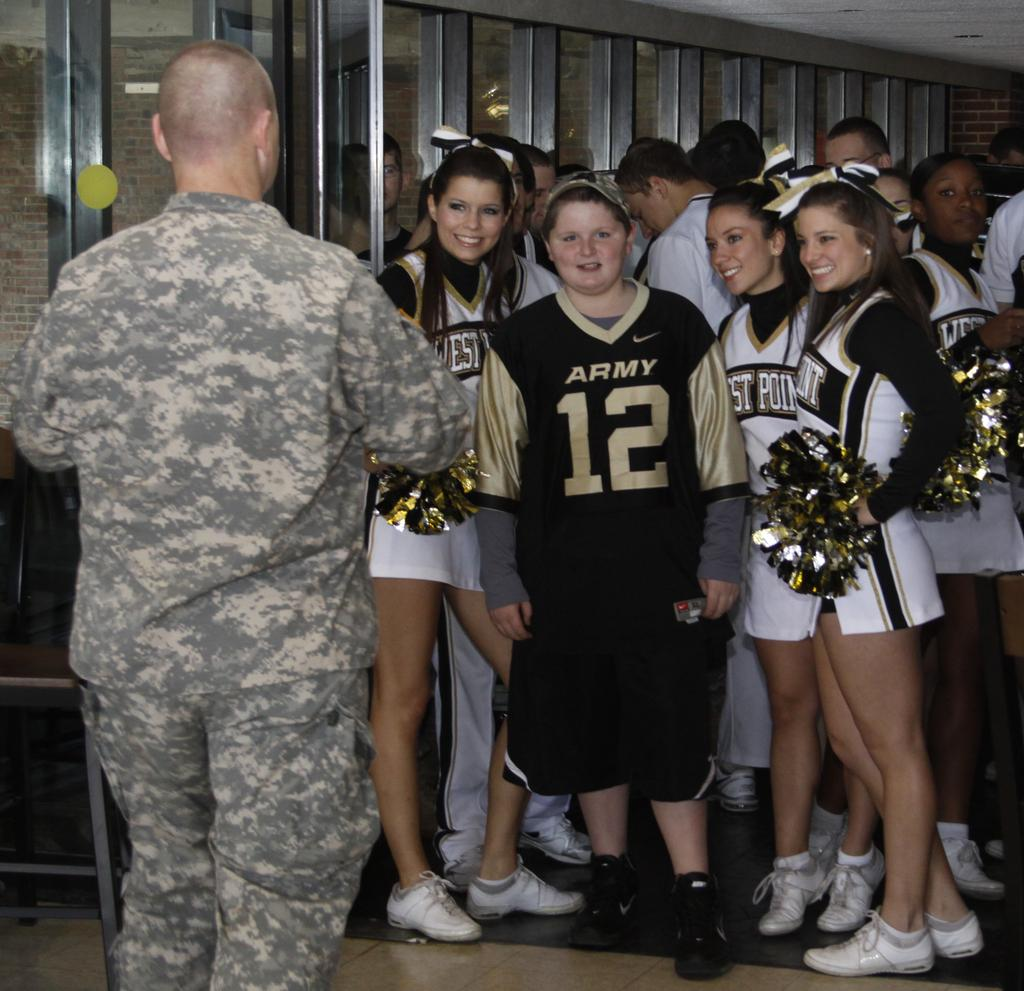<image>
Provide a brief description of the given image. A young man in a camo hat and a shirt that says Army is surrounded by cheerleaders. 